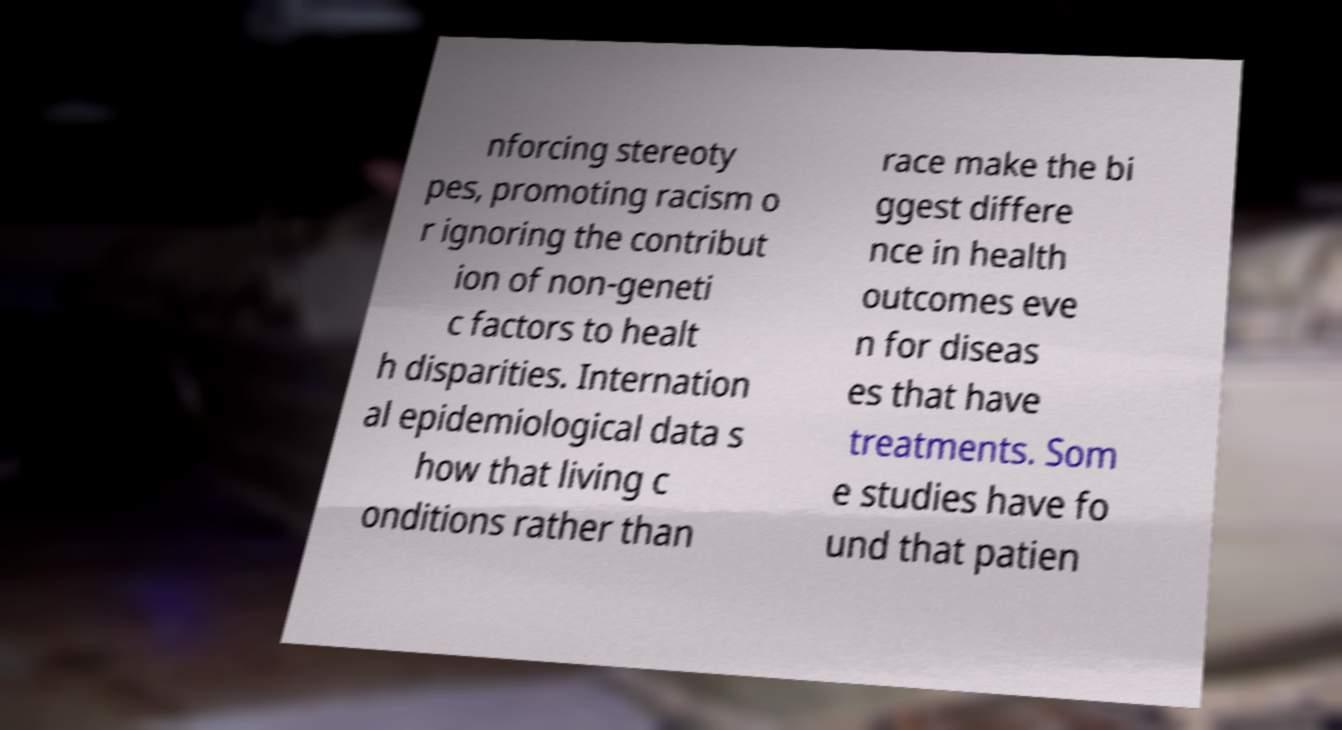What messages or text are displayed in this image? I need them in a readable, typed format. nforcing stereoty pes, promoting racism o r ignoring the contribut ion of non-geneti c factors to healt h disparities. Internation al epidemiological data s how that living c onditions rather than race make the bi ggest differe nce in health outcomes eve n for diseas es that have treatments. Som e studies have fo und that patien 